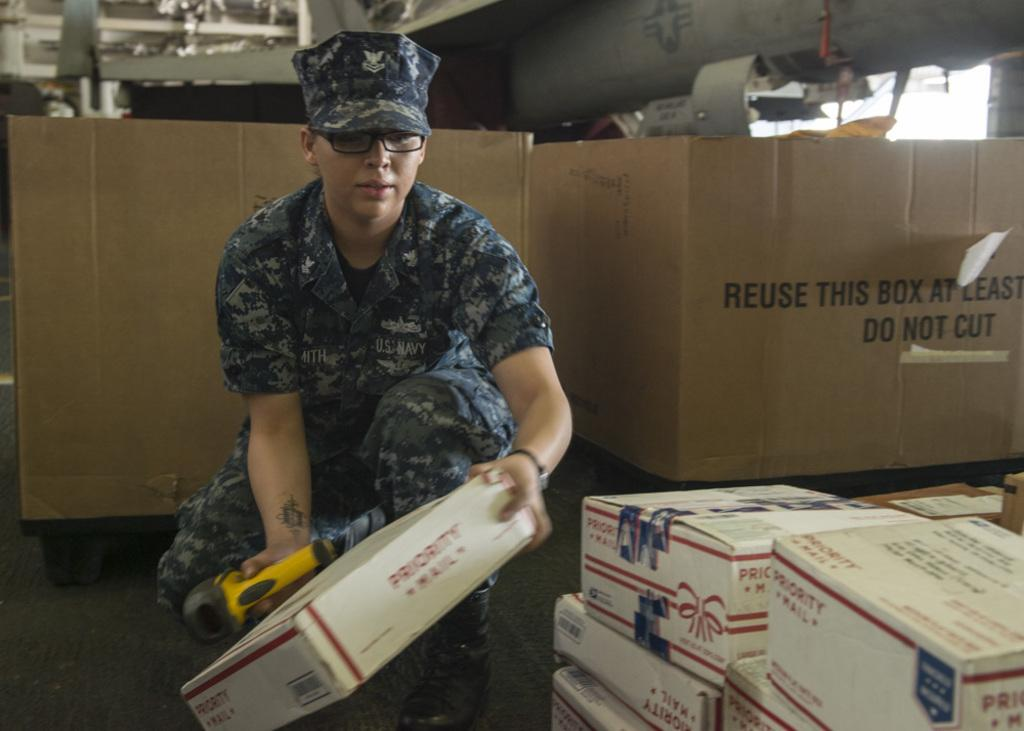<image>
Share a concise interpretation of the image provided. A person in uniform working with boxes of priority mail. 